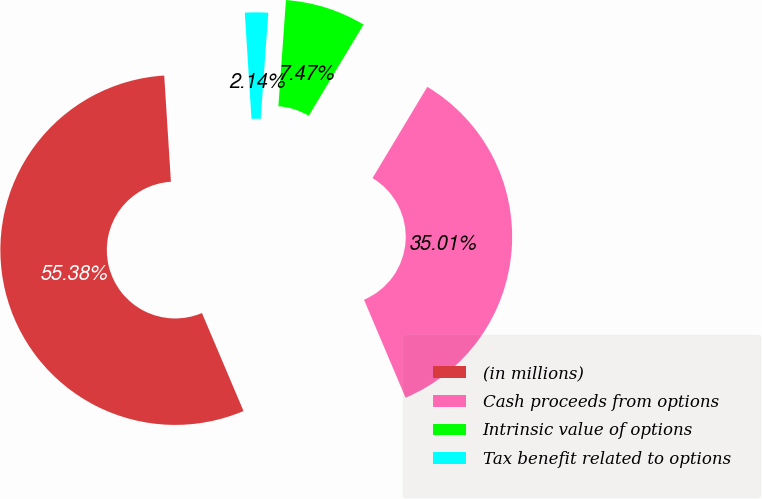Convert chart. <chart><loc_0><loc_0><loc_500><loc_500><pie_chart><fcel>(in millions)<fcel>Cash proceeds from options<fcel>Intrinsic value of options<fcel>Tax benefit related to options<nl><fcel>55.38%<fcel>35.01%<fcel>7.47%<fcel>2.14%<nl></chart> 